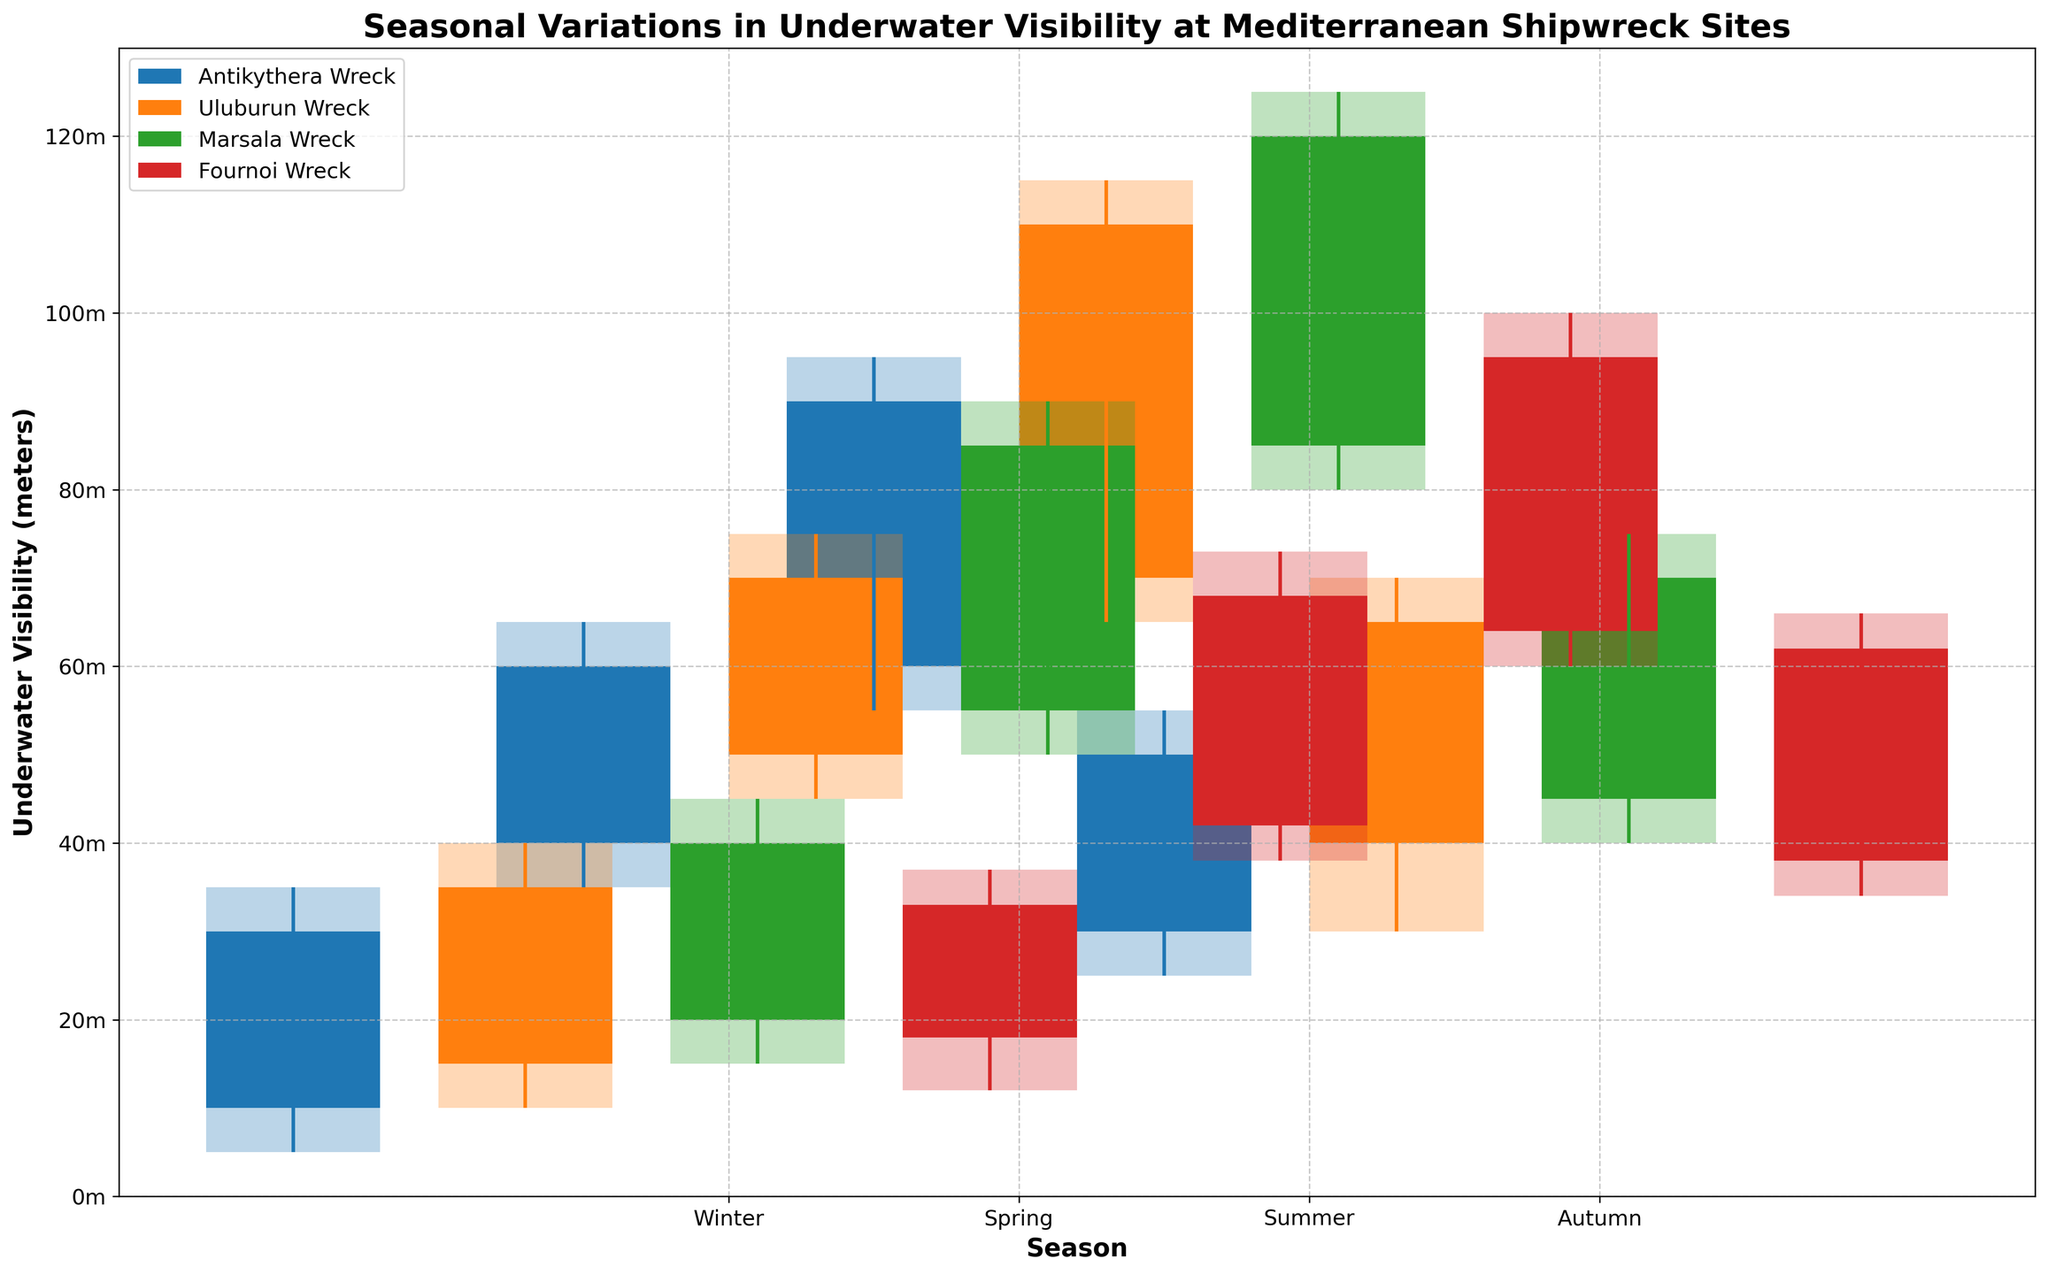What is the title of the figure? The title is typically located at the top of the figure. By reading the title, you can understand the general topic of the figure.
Answer: Seasonal Variations in Underwater Visibility at Mediterranean Shipwreck Sites Which season has the highest underwater visibility at the Uluburun Wreck site? We need to look at the height (top edge) of the bars representing the visibility in each season for the Uluburun Wreck site. The highest bar indicates the season with the highest visibility.
Answer: Summer Among the seasons represented, which one shows the largest range of visibility at the Antikythera Wreck? The range of visibility is determined by the difference between the High and Low values of the bars. By checking all seasons, we see which has the largest difference.
Answer: Summer Compare the underwater visibility between Spring and Autumn at the Marsala Wreck site. Which season has a higher median visibility? The median visibility can be approximated as the middle of the bar for each specific site and season. By visually comparing, we determine which bar has a higher midpoint.
Answer: Spring What is the average increase in visibility from Winter to Summer for the Fournoi Wreck site? Calculate the increase for each season step (Winter to Spring, Spring to Summer) and then find the average: (Spring Open - Winter Close) + (Summer High - Spring Low) / 2
Answer: 47.5 How does the Winter visibility at the Fournoi Wreck compare to the Summer visibility at the Antikythera Wreck? Compare the heights of the two bars. The Fournoi Winter's highest visibility is at 37, while the Antikythera Summer's highest visibility is at 95.
Answer: Significantly lower Identify the outliers in underwater visibility across all seasons and sites. Outliers are data points significantly higher or lower than the typical range. In this dataset, values that deviate noticeably like the Summer visibility at the Marsala Wreck can be considered as outliers.
Answer: Marsala Wreck Summer (125 meters) Which season at the Antikythera Wreck has the smallest difference between the open and close visibility measurements? The smallest difference between open and close visibility can be found by visually narrowing down the shortest bar between "Open" and "Close" for the Antikythera Wreck site.
Answer: Winter Rank the shipwreck sites by highest visibility during the Winter season. Analyze the Winter section for each site and compare the highest edges of the bars. Rank them in decreasing order.
Answer: Marsala, Uluburun, Fournoi, Antikythera 